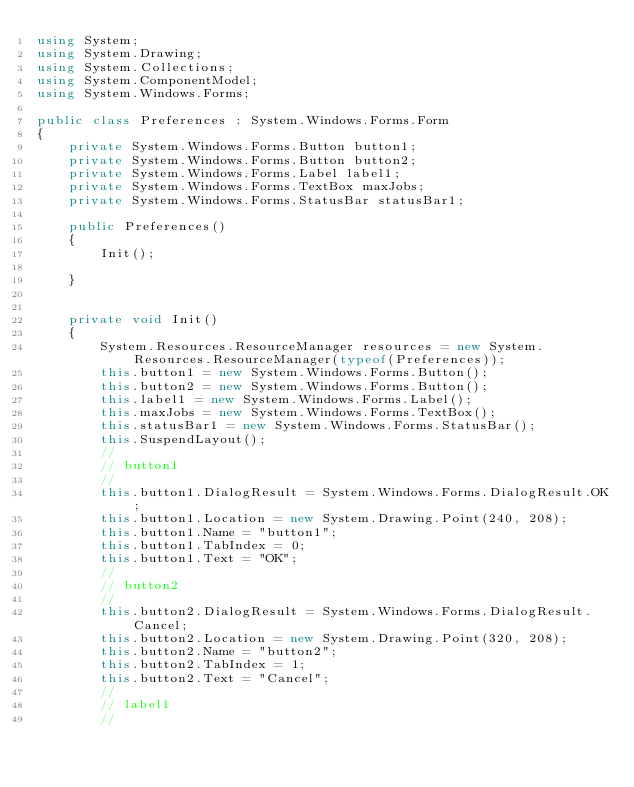<code> <loc_0><loc_0><loc_500><loc_500><_C#_>using System;
using System.Drawing;
using System.Collections;
using System.ComponentModel;
using System.Windows.Forms;

public class Preferences : System.Windows.Forms.Form
{
    private System.Windows.Forms.Button button1;
    private System.Windows.Forms.Button button2;
    private System.Windows.Forms.Label label1;
    private System.Windows.Forms.TextBox maxJobs;
    private System.Windows.Forms.StatusBar statusBar1;

    public Preferences()
    {
        Init();

    }


    private void Init()
    {
        System.Resources.ResourceManager resources = new System.Resources.ResourceManager(typeof(Preferences));
        this.button1 = new System.Windows.Forms.Button();
        this.button2 = new System.Windows.Forms.Button();
        this.label1 = new System.Windows.Forms.Label();
        this.maxJobs = new System.Windows.Forms.TextBox();
        this.statusBar1 = new System.Windows.Forms.StatusBar();
        this.SuspendLayout();
        // 
        // button1
        // 
        this.button1.DialogResult = System.Windows.Forms.DialogResult.OK;
        this.button1.Location = new System.Drawing.Point(240, 208);
        this.button1.Name = "button1";
        this.button1.TabIndex = 0;
        this.button1.Text = "OK";
        // 
        // button2
        // 
        this.button2.DialogResult = System.Windows.Forms.DialogResult.Cancel;
        this.button2.Location = new System.Drawing.Point(320, 208);
        this.button2.Name = "button2";
        this.button2.TabIndex = 1;
        this.button2.Text = "Cancel";
        // 
        // label1
        // </code> 